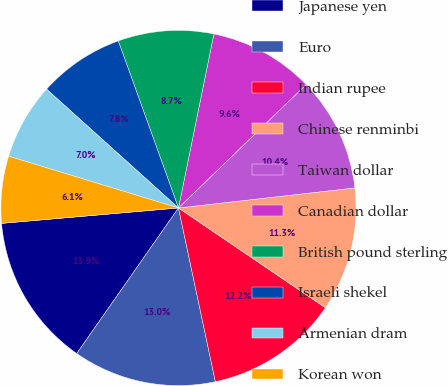Convert chart to OTSL. <chart><loc_0><loc_0><loc_500><loc_500><pie_chart><fcel>Japanese yen<fcel>Euro<fcel>Indian rupee<fcel>Chinese renminbi<fcel>Taiwan dollar<fcel>Canadian dollar<fcel>British pound sterling<fcel>Israeli shekel<fcel>Armenian dram<fcel>Korean won<nl><fcel>13.91%<fcel>13.04%<fcel>12.17%<fcel>11.3%<fcel>10.43%<fcel>9.57%<fcel>8.7%<fcel>7.83%<fcel>6.96%<fcel>6.09%<nl></chart> 